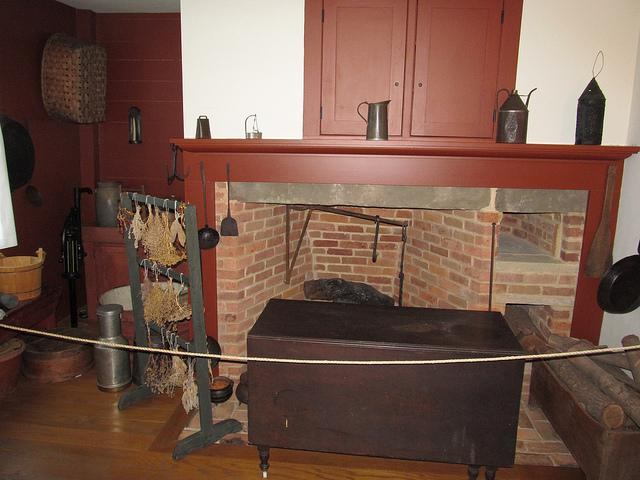Why is the area in the room roped off? Please explain your reasoning. historical significance. This area of a museum or historical home has very old artifacts in it, and any tampering by humans could potentially damage them. since many tourists ignore "do not touch" signs, ropes are employed to protect the valuable pieces. 